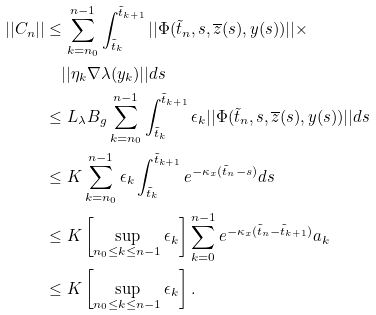Convert formula to latex. <formula><loc_0><loc_0><loc_500><loc_500>| | C _ { n } | | & \leq \sum _ { k = { n _ { 0 } } } ^ { n - 1 } \int _ { \tilde { t } _ { k } } ^ { \tilde { t } _ { k + 1 } } | | \Phi ( \tilde { t } _ { n } , s , \overline { z } ( s ) , y ( s ) ) | | \times \\ & \quad | | \eta _ { k } \nabla \lambda ( y _ { k } ) | | d s \\ & \leq L _ { \lambda } B _ { g } \sum _ { k = { n _ { 0 } } } ^ { n - 1 } \int _ { \tilde { t } _ { k } } ^ { \tilde { t } _ { k + 1 } } \epsilon _ { k } | | \Phi ( \tilde { t } _ { n } , s , \overline { z } ( s ) , y ( s ) ) | | d s \\ & \leq K \sum _ { k = { n _ { 0 } } } ^ { n - 1 } \epsilon _ { k } \int _ { \tilde { t } _ { k } } ^ { \tilde { t } _ { k + 1 } } e ^ { - \kappa _ { x } ( \tilde { t } _ { n } - s ) } d s \\ & \leq K \left [ \sup _ { { n _ { 0 } } \leq k \leq n - 1 } \epsilon _ { k } \right ] \sum _ { k = 0 } ^ { n - 1 } e ^ { - \kappa _ { x } ( \tilde { t } _ { n } - \tilde { t } _ { k + 1 } ) } a _ { k } \\ & \leq K \left [ \sup _ { { n _ { 0 } } \leq k \leq n - 1 } \epsilon _ { k } \right ] .</formula> 